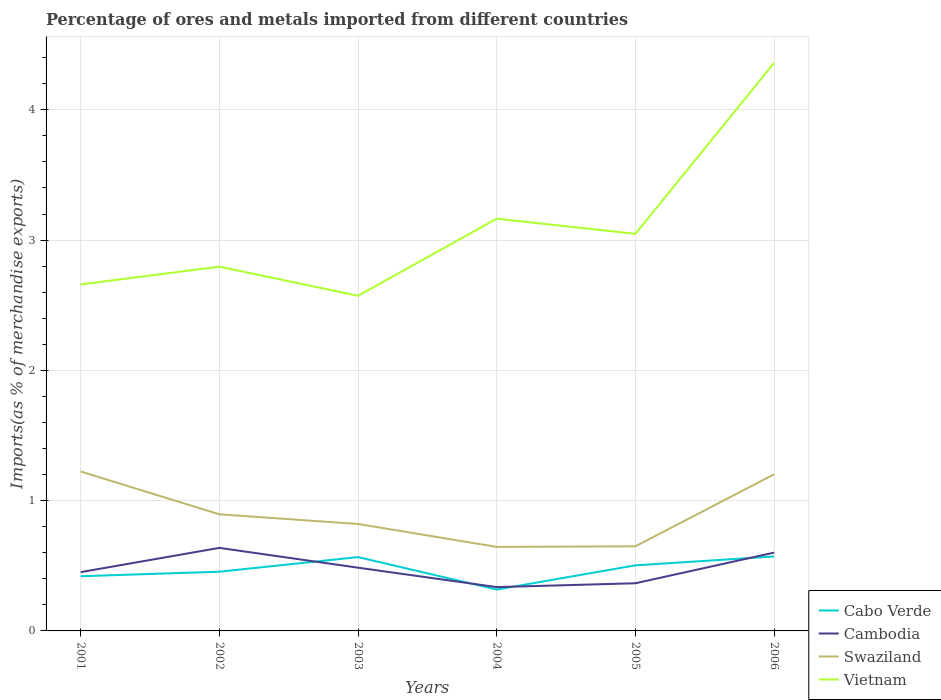Is the number of lines equal to the number of legend labels?
Your response must be concise. Yes. Across all years, what is the maximum percentage of imports to different countries in Vietnam?
Your response must be concise. 2.57. In which year was the percentage of imports to different countries in Vietnam maximum?
Keep it short and to the point. 2003. What is the total percentage of imports to different countries in Cabo Verde in the graph?
Make the answer very short. -0.15. What is the difference between the highest and the second highest percentage of imports to different countries in Vietnam?
Offer a very short reply. 1.79. What is the difference between the highest and the lowest percentage of imports to different countries in Cambodia?
Provide a succinct answer. 3. How many lines are there?
Offer a terse response. 4. What is the difference between two consecutive major ticks on the Y-axis?
Give a very brief answer. 1. Are the values on the major ticks of Y-axis written in scientific E-notation?
Offer a very short reply. No. Does the graph contain any zero values?
Provide a short and direct response. No. Where does the legend appear in the graph?
Keep it short and to the point. Bottom right. How are the legend labels stacked?
Your response must be concise. Vertical. What is the title of the graph?
Provide a short and direct response. Percentage of ores and metals imported from different countries. What is the label or title of the Y-axis?
Make the answer very short. Imports(as % of merchandise exports). What is the Imports(as % of merchandise exports) of Cabo Verde in 2001?
Give a very brief answer. 0.42. What is the Imports(as % of merchandise exports) of Cambodia in 2001?
Your answer should be very brief. 0.45. What is the Imports(as % of merchandise exports) of Swaziland in 2001?
Offer a terse response. 1.22. What is the Imports(as % of merchandise exports) in Vietnam in 2001?
Ensure brevity in your answer.  2.66. What is the Imports(as % of merchandise exports) in Cabo Verde in 2002?
Make the answer very short. 0.45. What is the Imports(as % of merchandise exports) of Cambodia in 2002?
Offer a terse response. 0.64. What is the Imports(as % of merchandise exports) in Swaziland in 2002?
Offer a very short reply. 0.9. What is the Imports(as % of merchandise exports) in Vietnam in 2002?
Your response must be concise. 2.8. What is the Imports(as % of merchandise exports) of Cabo Verde in 2003?
Offer a very short reply. 0.57. What is the Imports(as % of merchandise exports) of Cambodia in 2003?
Give a very brief answer. 0.49. What is the Imports(as % of merchandise exports) of Swaziland in 2003?
Provide a short and direct response. 0.82. What is the Imports(as % of merchandise exports) of Vietnam in 2003?
Make the answer very short. 2.57. What is the Imports(as % of merchandise exports) in Cabo Verde in 2004?
Provide a succinct answer. 0.32. What is the Imports(as % of merchandise exports) of Cambodia in 2004?
Offer a very short reply. 0.34. What is the Imports(as % of merchandise exports) of Swaziland in 2004?
Offer a very short reply. 0.65. What is the Imports(as % of merchandise exports) in Vietnam in 2004?
Give a very brief answer. 3.16. What is the Imports(as % of merchandise exports) of Cabo Verde in 2005?
Your response must be concise. 0.5. What is the Imports(as % of merchandise exports) in Cambodia in 2005?
Ensure brevity in your answer.  0.37. What is the Imports(as % of merchandise exports) of Swaziland in 2005?
Your answer should be compact. 0.65. What is the Imports(as % of merchandise exports) of Vietnam in 2005?
Make the answer very short. 3.05. What is the Imports(as % of merchandise exports) in Cabo Verde in 2006?
Provide a succinct answer. 0.57. What is the Imports(as % of merchandise exports) in Cambodia in 2006?
Keep it short and to the point. 0.6. What is the Imports(as % of merchandise exports) of Swaziland in 2006?
Keep it short and to the point. 1.2. What is the Imports(as % of merchandise exports) in Vietnam in 2006?
Make the answer very short. 4.36. Across all years, what is the maximum Imports(as % of merchandise exports) in Cabo Verde?
Offer a terse response. 0.57. Across all years, what is the maximum Imports(as % of merchandise exports) in Cambodia?
Make the answer very short. 0.64. Across all years, what is the maximum Imports(as % of merchandise exports) in Swaziland?
Make the answer very short. 1.22. Across all years, what is the maximum Imports(as % of merchandise exports) in Vietnam?
Provide a succinct answer. 4.36. Across all years, what is the minimum Imports(as % of merchandise exports) in Cabo Verde?
Provide a short and direct response. 0.32. Across all years, what is the minimum Imports(as % of merchandise exports) of Cambodia?
Offer a terse response. 0.34. Across all years, what is the minimum Imports(as % of merchandise exports) in Swaziland?
Give a very brief answer. 0.65. Across all years, what is the minimum Imports(as % of merchandise exports) of Vietnam?
Ensure brevity in your answer.  2.57. What is the total Imports(as % of merchandise exports) of Cabo Verde in the graph?
Ensure brevity in your answer.  2.83. What is the total Imports(as % of merchandise exports) in Cambodia in the graph?
Provide a succinct answer. 2.88. What is the total Imports(as % of merchandise exports) in Swaziland in the graph?
Your response must be concise. 5.44. What is the total Imports(as % of merchandise exports) in Vietnam in the graph?
Your answer should be very brief. 18.6. What is the difference between the Imports(as % of merchandise exports) in Cabo Verde in 2001 and that in 2002?
Your response must be concise. -0.03. What is the difference between the Imports(as % of merchandise exports) in Cambodia in 2001 and that in 2002?
Your answer should be compact. -0.19. What is the difference between the Imports(as % of merchandise exports) in Swaziland in 2001 and that in 2002?
Keep it short and to the point. 0.33. What is the difference between the Imports(as % of merchandise exports) in Vietnam in 2001 and that in 2002?
Provide a succinct answer. -0.14. What is the difference between the Imports(as % of merchandise exports) in Cabo Verde in 2001 and that in 2003?
Your answer should be compact. -0.15. What is the difference between the Imports(as % of merchandise exports) in Cambodia in 2001 and that in 2003?
Your response must be concise. -0.03. What is the difference between the Imports(as % of merchandise exports) in Swaziland in 2001 and that in 2003?
Your response must be concise. 0.4. What is the difference between the Imports(as % of merchandise exports) in Vietnam in 2001 and that in 2003?
Provide a short and direct response. 0.09. What is the difference between the Imports(as % of merchandise exports) in Cabo Verde in 2001 and that in 2004?
Provide a short and direct response. 0.1. What is the difference between the Imports(as % of merchandise exports) of Cambodia in 2001 and that in 2004?
Your answer should be compact. 0.11. What is the difference between the Imports(as % of merchandise exports) in Swaziland in 2001 and that in 2004?
Offer a very short reply. 0.58. What is the difference between the Imports(as % of merchandise exports) in Vietnam in 2001 and that in 2004?
Offer a terse response. -0.51. What is the difference between the Imports(as % of merchandise exports) in Cabo Verde in 2001 and that in 2005?
Your answer should be compact. -0.08. What is the difference between the Imports(as % of merchandise exports) in Cambodia in 2001 and that in 2005?
Offer a very short reply. 0.09. What is the difference between the Imports(as % of merchandise exports) in Swaziland in 2001 and that in 2005?
Provide a short and direct response. 0.57. What is the difference between the Imports(as % of merchandise exports) of Vietnam in 2001 and that in 2005?
Offer a terse response. -0.39. What is the difference between the Imports(as % of merchandise exports) in Cabo Verde in 2001 and that in 2006?
Give a very brief answer. -0.15. What is the difference between the Imports(as % of merchandise exports) of Cambodia in 2001 and that in 2006?
Your answer should be very brief. -0.15. What is the difference between the Imports(as % of merchandise exports) in Swaziland in 2001 and that in 2006?
Ensure brevity in your answer.  0.02. What is the difference between the Imports(as % of merchandise exports) in Vietnam in 2001 and that in 2006?
Give a very brief answer. -1.7. What is the difference between the Imports(as % of merchandise exports) of Cabo Verde in 2002 and that in 2003?
Your answer should be very brief. -0.11. What is the difference between the Imports(as % of merchandise exports) of Cambodia in 2002 and that in 2003?
Provide a short and direct response. 0.15. What is the difference between the Imports(as % of merchandise exports) in Swaziland in 2002 and that in 2003?
Ensure brevity in your answer.  0.07. What is the difference between the Imports(as % of merchandise exports) of Vietnam in 2002 and that in 2003?
Your response must be concise. 0.22. What is the difference between the Imports(as % of merchandise exports) in Cabo Verde in 2002 and that in 2004?
Your response must be concise. 0.14. What is the difference between the Imports(as % of merchandise exports) in Cambodia in 2002 and that in 2004?
Ensure brevity in your answer.  0.3. What is the difference between the Imports(as % of merchandise exports) of Swaziland in 2002 and that in 2004?
Give a very brief answer. 0.25. What is the difference between the Imports(as % of merchandise exports) of Vietnam in 2002 and that in 2004?
Offer a very short reply. -0.37. What is the difference between the Imports(as % of merchandise exports) of Cabo Verde in 2002 and that in 2005?
Your response must be concise. -0.05. What is the difference between the Imports(as % of merchandise exports) of Cambodia in 2002 and that in 2005?
Your answer should be compact. 0.27. What is the difference between the Imports(as % of merchandise exports) of Swaziland in 2002 and that in 2005?
Your response must be concise. 0.25. What is the difference between the Imports(as % of merchandise exports) of Vietnam in 2002 and that in 2005?
Offer a very short reply. -0.25. What is the difference between the Imports(as % of merchandise exports) of Cabo Verde in 2002 and that in 2006?
Your answer should be compact. -0.12. What is the difference between the Imports(as % of merchandise exports) in Cambodia in 2002 and that in 2006?
Your response must be concise. 0.04. What is the difference between the Imports(as % of merchandise exports) in Swaziland in 2002 and that in 2006?
Make the answer very short. -0.31. What is the difference between the Imports(as % of merchandise exports) in Vietnam in 2002 and that in 2006?
Your answer should be very brief. -1.56. What is the difference between the Imports(as % of merchandise exports) in Cabo Verde in 2003 and that in 2004?
Make the answer very short. 0.25. What is the difference between the Imports(as % of merchandise exports) in Cambodia in 2003 and that in 2004?
Your answer should be very brief. 0.15. What is the difference between the Imports(as % of merchandise exports) in Swaziland in 2003 and that in 2004?
Offer a very short reply. 0.18. What is the difference between the Imports(as % of merchandise exports) in Vietnam in 2003 and that in 2004?
Provide a succinct answer. -0.59. What is the difference between the Imports(as % of merchandise exports) in Cabo Verde in 2003 and that in 2005?
Offer a very short reply. 0.06. What is the difference between the Imports(as % of merchandise exports) of Cambodia in 2003 and that in 2005?
Your answer should be compact. 0.12. What is the difference between the Imports(as % of merchandise exports) in Swaziland in 2003 and that in 2005?
Keep it short and to the point. 0.17. What is the difference between the Imports(as % of merchandise exports) in Vietnam in 2003 and that in 2005?
Ensure brevity in your answer.  -0.48. What is the difference between the Imports(as % of merchandise exports) in Cabo Verde in 2003 and that in 2006?
Your answer should be compact. -0. What is the difference between the Imports(as % of merchandise exports) in Cambodia in 2003 and that in 2006?
Keep it short and to the point. -0.12. What is the difference between the Imports(as % of merchandise exports) in Swaziland in 2003 and that in 2006?
Provide a succinct answer. -0.38. What is the difference between the Imports(as % of merchandise exports) of Vietnam in 2003 and that in 2006?
Your answer should be compact. -1.79. What is the difference between the Imports(as % of merchandise exports) of Cabo Verde in 2004 and that in 2005?
Give a very brief answer. -0.19. What is the difference between the Imports(as % of merchandise exports) in Cambodia in 2004 and that in 2005?
Provide a succinct answer. -0.03. What is the difference between the Imports(as % of merchandise exports) in Swaziland in 2004 and that in 2005?
Provide a succinct answer. -0. What is the difference between the Imports(as % of merchandise exports) of Vietnam in 2004 and that in 2005?
Offer a very short reply. 0.12. What is the difference between the Imports(as % of merchandise exports) in Cabo Verde in 2004 and that in 2006?
Provide a short and direct response. -0.25. What is the difference between the Imports(as % of merchandise exports) of Cambodia in 2004 and that in 2006?
Your answer should be very brief. -0.26. What is the difference between the Imports(as % of merchandise exports) of Swaziland in 2004 and that in 2006?
Offer a terse response. -0.56. What is the difference between the Imports(as % of merchandise exports) in Vietnam in 2004 and that in 2006?
Your answer should be very brief. -1.2. What is the difference between the Imports(as % of merchandise exports) of Cabo Verde in 2005 and that in 2006?
Your answer should be compact. -0.07. What is the difference between the Imports(as % of merchandise exports) of Cambodia in 2005 and that in 2006?
Provide a succinct answer. -0.24. What is the difference between the Imports(as % of merchandise exports) of Swaziland in 2005 and that in 2006?
Give a very brief answer. -0.55. What is the difference between the Imports(as % of merchandise exports) of Vietnam in 2005 and that in 2006?
Your answer should be very brief. -1.31. What is the difference between the Imports(as % of merchandise exports) in Cabo Verde in 2001 and the Imports(as % of merchandise exports) in Cambodia in 2002?
Keep it short and to the point. -0.22. What is the difference between the Imports(as % of merchandise exports) in Cabo Verde in 2001 and the Imports(as % of merchandise exports) in Swaziland in 2002?
Provide a succinct answer. -0.48. What is the difference between the Imports(as % of merchandise exports) in Cabo Verde in 2001 and the Imports(as % of merchandise exports) in Vietnam in 2002?
Offer a very short reply. -2.38. What is the difference between the Imports(as % of merchandise exports) in Cambodia in 2001 and the Imports(as % of merchandise exports) in Swaziland in 2002?
Give a very brief answer. -0.44. What is the difference between the Imports(as % of merchandise exports) in Cambodia in 2001 and the Imports(as % of merchandise exports) in Vietnam in 2002?
Make the answer very short. -2.34. What is the difference between the Imports(as % of merchandise exports) of Swaziland in 2001 and the Imports(as % of merchandise exports) of Vietnam in 2002?
Provide a succinct answer. -1.57. What is the difference between the Imports(as % of merchandise exports) of Cabo Verde in 2001 and the Imports(as % of merchandise exports) of Cambodia in 2003?
Your answer should be very brief. -0.07. What is the difference between the Imports(as % of merchandise exports) in Cabo Verde in 2001 and the Imports(as % of merchandise exports) in Swaziland in 2003?
Offer a very short reply. -0.4. What is the difference between the Imports(as % of merchandise exports) of Cabo Verde in 2001 and the Imports(as % of merchandise exports) of Vietnam in 2003?
Offer a very short reply. -2.15. What is the difference between the Imports(as % of merchandise exports) in Cambodia in 2001 and the Imports(as % of merchandise exports) in Swaziland in 2003?
Give a very brief answer. -0.37. What is the difference between the Imports(as % of merchandise exports) of Cambodia in 2001 and the Imports(as % of merchandise exports) of Vietnam in 2003?
Your response must be concise. -2.12. What is the difference between the Imports(as % of merchandise exports) in Swaziland in 2001 and the Imports(as % of merchandise exports) in Vietnam in 2003?
Offer a very short reply. -1.35. What is the difference between the Imports(as % of merchandise exports) of Cabo Verde in 2001 and the Imports(as % of merchandise exports) of Cambodia in 2004?
Keep it short and to the point. 0.08. What is the difference between the Imports(as % of merchandise exports) in Cabo Verde in 2001 and the Imports(as % of merchandise exports) in Swaziland in 2004?
Your answer should be compact. -0.23. What is the difference between the Imports(as % of merchandise exports) of Cabo Verde in 2001 and the Imports(as % of merchandise exports) of Vietnam in 2004?
Make the answer very short. -2.74. What is the difference between the Imports(as % of merchandise exports) in Cambodia in 2001 and the Imports(as % of merchandise exports) in Swaziland in 2004?
Offer a very short reply. -0.19. What is the difference between the Imports(as % of merchandise exports) in Cambodia in 2001 and the Imports(as % of merchandise exports) in Vietnam in 2004?
Offer a very short reply. -2.71. What is the difference between the Imports(as % of merchandise exports) in Swaziland in 2001 and the Imports(as % of merchandise exports) in Vietnam in 2004?
Give a very brief answer. -1.94. What is the difference between the Imports(as % of merchandise exports) in Cabo Verde in 2001 and the Imports(as % of merchandise exports) in Cambodia in 2005?
Your answer should be compact. 0.05. What is the difference between the Imports(as % of merchandise exports) in Cabo Verde in 2001 and the Imports(as % of merchandise exports) in Swaziland in 2005?
Provide a short and direct response. -0.23. What is the difference between the Imports(as % of merchandise exports) in Cabo Verde in 2001 and the Imports(as % of merchandise exports) in Vietnam in 2005?
Offer a terse response. -2.63. What is the difference between the Imports(as % of merchandise exports) of Cambodia in 2001 and the Imports(as % of merchandise exports) of Swaziland in 2005?
Your answer should be very brief. -0.2. What is the difference between the Imports(as % of merchandise exports) in Cambodia in 2001 and the Imports(as % of merchandise exports) in Vietnam in 2005?
Offer a terse response. -2.6. What is the difference between the Imports(as % of merchandise exports) of Swaziland in 2001 and the Imports(as % of merchandise exports) of Vietnam in 2005?
Provide a short and direct response. -1.82. What is the difference between the Imports(as % of merchandise exports) of Cabo Verde in 2001 and the Imports(as % of merchandise exports) of Cambodia in 2006?
Ensure brevity in your answer.  -0.18. What is the difference between the Imports(as % of merchandise exports) in Cabo Verde in 2001 and the Imports(as % of merchandise exports) in Swaziland in 2006?
Your answer should be very brief. -0.78. What is the difference between the Imports(as % of merchandise exports) in Cabo Verde in 2001 and the Imports(as % of merchandise exports) in Vietnam in 2006?
Keep it short and to the point. -3.94. What is the difference between the Imports(as % of merchandise exports) of Cambodia in 2001 and the Imports(as % of merchandise exports) of Swaziland in 2006?
Provide a succinct answer. -0.75. What is the difference between the Imports(as % of merchandise exports) of Cambodia in 2001 and the Imports(as % of merchandise exports) of Vietnam in 2006?
Offer a terse response. -3.91. What is the difference between the Imports(as % of merchandise exports) of Swaziland in 2001 and the Imports(as % of merchandise exports) of Vietnam in 2006?
Your response must be concise. -3.14. What is the difference between the Imports(as % of merchandise exports) of Cabo Verde in 2002 and the Imports(as % of merchandise exports) of Cambodia in 2003?
Make the answer very short. -0.03. What is the difference between the Imports(as % of merchandise exports) of Cabo Verde in 2002 and the Imports(as % of merchandise exports) of Swaziland in 2003?
Ensure brevity in your answer.  -0.37. What is the difference between the Imports(as % of merchandise exports) of Cabo Verde in 2002 and the Imports(as % of merchandise exports) of Vietnam in 2003?
Make the answer very short. -2.12. What is the difference between the Imports(as % of merchandise exports) in Cambodia in 2002 and the Imports(as % of merchandise exports) in Swaziland in 2003?
Your response must be concise. -0.18. What is the difference between the Imports(as % of merchandise exports) in Cambodia in 2002 and the Imports(as % of merchandise exports) in Vietnam in 2003?
Ensure brevity in your answer.  -1.94. What is the difference between the Imports(as % of merchandise exports) in Swaziland in 2002 and the Imports(as % of merchandise exports) in Vietnam in 2003?
Make the answer very short. -1.68. What is the difference between the Imports(as % of merchandise exports) of Cabo Verde in 2002 and the Imports(as % of merchandise exports) of Cambodia in 2004?
Your response must be concise. 0.12. What is the difference between the Imports(as % of merchandise exports) in Cabo Verde in 2002 and the Imports(as % of merchandise exports) in Swaziland in 2004?
Provide a succinct answer. -0.19. What is the difference between the Imports(as % of merchandise exports) in Cabo Verde in 2002 and the Imports(as % of merchandise exports) in Vietnam in 2004?
Offer a terse response. -2.71. What is the difference between the Imports(as % of merchandise exports) of Cambodia in 2002 and the Imports(as % of merchandise exports) of Swaziland in 2004?
Provide a succinct answer. -0.01. What is the difference between the Imports(as % of merchandise exports) in Cambodia in 2002 and the Imports(as % of merchandise exports) in Vietnam in 2004?
Offer a very short reply. -2.53. What is the difference between the Imports(as % of merchandise exports) of Swaziland in 2002 and the Imports(as % of merchandise exports) of Vietnam in 2004?
Ensure brevity in your answer.  -2.27. What is the difference between the Imports(as % of merchandise exports) in Cabo Verde in 2002 and the Imports(as % of merchandise exports) in Cambodia in 2005?
Offer a terse response. 0.09. What is the difference between the Imports(as % of merchandise exports) in Cabo Verde in 2002 and the Imports(as % of merchandise exports) in Swaziland in 2005?
Offer a terse response. -0.19. What is the difference between the Imports(as % of merchandise exports) of Cabo Verde in 2002 and the Imports(as % of merchandise exports) of Vietnam in 2005?
Make the answer very short. -2.59. What is the difference between the Imports(as % of merchandise exports) of Cambodia in 2002 and the Imports(as % of merchandise exports) of Swaziland in 2005?
Offer a terse response. -0.01. What is the difference between the Imports(as % of merchandise exports) in Cambodia in 2002 and the Imports(as % of merchandise exports) in Vietnam in 2005?
Provide a short and direct response. -2.41. What is the difference between the Imports(as % of merchandise exports) in Swaziland in 2002 and the Imports(as % of merchandise exports) in Vietnam in 2005?
Make the answer very short. -2.15. What is the difference between the Imports(as % of merchandise exports) of Cabo Verde in 2002 and the Imports(as % of merchandise exports) of Cambodia in 2006?
Provide a short and direct response. -0.15. What is the difference between the Imports(as % of merchandise exports) of Cabo Verde in 2002 and the Imports(as % of merchandise exports) of Swaziland in 2006?
Provide a succinct answer. -0.75. What is the difference between the Imports(as % of merchandise exports) of Cabo Verde in 2002 and the Imports(as % of merchandise exports) of Vietnam in 2006?
Offer a very short reply. -3.91. What is the difference between the Imports(as % of merchandise exports) in Cambodia in 2002 and the Imports(as % of merchandise exports) in Swaziland in 2006?
Your answer should be compact. -0.56. What is the difference between the Imports(as % of merchandise exports) in Cambodia in 2002 and the Imports(as % of merchandise exports) in Vietnam in 2006?
Give a very brief answer. -3.72. What is the difference between the Imports(as % of merchandise exports) of Swaziland in 2002 and the Imports(as % of merchandise exports) of Vietnam in 2006?
Offer a terse response. -3.46. What is the difference between the Imports(as % of merchandise exports) in Cabo Verde in 2003 and the Imports(as % of merchandise exports) in Cambodia in 2004?
Give a very brief answer. 0.23. What is the difference between the Imports(as % of merchandise exports) in Cabo Verde in 2003 and the Imports(as % of merchandise exports) in Swaziland in 2004?
Keep it short and to the point. -0.08. What is the difference between the Imports(as % of merchandise exports) of Cabo Verde in 2003 and the Imports(as % of merchandise exports) of Vietnam in 2004?
Provide a succinct answer. -2.6. What is the difference between the Imports(as % of merchandise exports) of Cambodia in 2003 and the Imports(as % of merchandise exports) of Swaziland in 2004?
Offer a very short reply. -0.16. What is the difference between the Imports(as % of merchandise exports) of Cambodia in 2003 and the Imports(as % of merchandise exports) of Vietnam in 2004?
Ensure brevity in your answer.  -2.68. What is the difference between the Imports(as % of merchandise exports) of Swaziland in 2003 and the Imports(as % of merchandise exports) of Vietnam in 2004?
Make the answer very short. -2.34. What is the difference between the Imports(as % of merchandise exports) of Cabo Verde in 2003 and the Imports(as % of merchandise exports) of Cambodia in 2005?
Make the answer very short. 0.2. What is the difference between the Imports(as % of merchandise exports) of Cabo Verde in 2003 and the Imports(as % of merchandise exports) of Swaziland in 2005?
Provide a short and direct response. -0.08. What is the difference between the Imports(as % of merchandise exports) of Cabo Verde in 2003 and the Imports(as % of merchandise exports) of Vietnam in 2005?
Ensure brevity in your answer.  -2.48. What is the difference between the Imports(as % of merchandise exports) in Cambodia in 2003 and the Imports(as % of merchandise exports) in Swaziland in 2005?
Your answer should be very brief. -0.16. What is the difference between the Imports(as % of merchandise exports) of Cambodia in 2003 and the Imports(as % of merchandise exports) of Vietnam in 2005?
Make the answer very short. -2.56. What is the difference between the Imports(as % of merchandise exports) of Swaziland in 2003 and the Imports(as % of merchandise exports) of Vietnam in 2005?
Give a very brief answer. -2.23. What is the difference between the Imports(as % of merchandise exports) of Cabo Verde in 2003 and the Imports(as % of merchandise exports) of Cambodia in 2006?
Keep it short and to the point. -0.03. What is the difference between the Imports(as % of merchandise exports) in Cabo Verde in 2003 and the Imports(as % of merchandise exports) in Swaziland in 2006?
Offer a terse response. -0.64. What is the difference between the Imports(as % of merchandise exports) of Cabo Verde in 2003 and the Imports(as % of merchandise exports) of Vietnam in 2006?
Make the answer very short. -3.79. What is the difference between the Imports(as % of merchandise exports) of Cambodia in 2003 and the Imports(as % of merchandise exports) of Swaziland in 2006?
Offer a terse response. -0.72. What is the difference between the Imports(as % of merchandise exports) in Cambodia in 2003 and the Imports(as % of merchandise exports) in Vietnam in 2006?
Make the answer very short. -3.87. What is the difference between the Imports(as % of merchandise exports) in Swaziland in 2003 and the Imports(as % of merchandise exports) in Vietnam in 2006?
Provide a succinct answer. -3.54. What is the difference between the Imports(as % of merchandise exports) in Cabo Verde in 2004 and the Imports(as % of merchandise exports) in Cambodia in 2005?
Your answer should be compact. -0.05. What is the difference between the Imports(as % of merchandise exports) of Cabo Verde in 2004 and the Imports(as % of merchandise exports) of Swaziland in 2005?
Your answer should be compact. -0.33. What is the difference between the Imports(as % of merchandise exports) in Cabo Verde in 2004 and the Imports(as % of merchandise exports) in Vietnam in 2005?
Your response must be concise. -2.73. What is the difference between the Imports(as % of merchandise exports) of Cambodia in 2004 and the Imports(as % of merchandise exports) of Swaziland in 2005?
Your answer should be compact. -0.31. What is the difference between the Imports(as % of merchandise exports) of Cambodia in 2004 and the Imports(as % of merchandise exports) of Vietnam in 2005?
Offer a very short reply. -2.71. What is the difference between the Imports(as % of merchandise exports) in Swaziland in 2004 and the Imports(as % of merchandise exports) in Vietnam in 2005?
Keep it short and to the point. -2.4. What is the difference between the Imports(as % of merchandise exports) in Cabo Verde in 2004 and the Imports(as % of merchandise exports) in Cambodia in 2006?
Your answer should be compact. -0.28. What is the difference between the Imports(as % of merchandise exports) in Cabo Verde in 2004 and the Imports(as % of merchandise exports) in Swaziland in 2006?
Your answer should be compact. -0.88. What is the difference between the Imports(as % of merchandise exports) of Cabo Verde in 2004 and the Imports(as % of merchandise exports) of Vietnam in 2006?
Give a very brief answer. -4.04. What is the difference between the Imports(as % of merchandise exports) in Cambodia in 2004 and the Imports(as % of merchandise exports) in Swaziland in 2006?
Provide a short and direct response. -0.87. What is the difference between the Imports(as % of merchandise exports) of Cambodia in 2004 and the Imports(as % of merchandise exports) of Vietnam in 2006?
Provide a succinct answer. -4.02. What is the difference between the Imports(as % of merchandise exports) of Swaziland in 2004 and the Imports(as % of merchandise exports) of Vietnam in 2006?
Keep it short and to the point. -3.71. What is the difference between the Imports(as % of merchandise exports) in Cabo Verde in 2005 and the Imports(as % of merchandise exports) in Cambodia in 2006?
Offer a very short reply. -0.1. What is the difference between the Imports(as % of merchandise exports) in Cabo Verde in 2005 and the Imports(as % of merchandise exports) in Swaziland in 2006?
Your answer should be compact. -0.7. What is the difference between the Imports(as % of merchandise exports) of Cabo Verde in 2005 and the Imports(as % of merchandise exports) of Vietnam in 2006?
Offer a terse response. -3.86. What is the difference between the Imports(as % of merchandise exports) in Cambodia in 2005 and the Imports(as % of merchandise exports) in Swaziland in 2006?
Provide a short and direct response. -0.84. What is the difference between the Imports(as % of merchandise exports) of Cambodia in 2005 and the Imports(as % of merchandise exports) of Vietnam in 2006?
Keep it short and to the point. -3.99. What is the difference between the Imports(as % of merchandise exports) of Swaziland in 2005 and the Imports(as % of merchandise exports) of Vietnam in 2006?
Provide a succinct answer. -3.71. What is the average Imports(as % of merchandise exports) of Cabo Verde per year?
Ensure brevity in your answer.  0.47. What is the average Imports(as % of merchandise exports) of Cambodia per year?
Ensure brevity in your answer.  0.48. What is the average Imports(as % of merchandise exports) of Swaziland per year?
Your answer should be compact. 0.91. In the year 2001, what is the difference between the Imports(as % of merchandise exports) of Cabo Verde and Imports(as % of merchandise exports) of Cambodia?
Offer a terse response. -0.03. In the year 2001, what is the difference between the Imports(as % of merchandise exports) of Cabo Verde and Imports(as % of merchandise exports) of Swaziland?
Make the answer very short. -0.8. In the year 2001, what is the difference between the Imports(as % of merchandise exports) in Cabo Verde and Imports(as % of merchandise exports) in Vietnam?
Your answer should be very brief. -2.24. In the year 2001, what is the difference between the Imports(as % of merchandise exports) in Cambodia and Imports(as % of merchandise exports) in Swaziland?
Make the answer very short. -0.77. In the year 2001, what is the difference between the Imports(as % of merchandise exports) of Cambodia and Imports(as % of merchandise exports) of Vietnam?
Keep it short and to the point. -2.21. In the year 2001, what is the difference between the Imports(as % of merchandise exports) in Swaziland and Imports(as % of merchandise exports) in Vietnam?
Offer a terse response. -1.44. In the year 2002, what is the difference between the Imports(as % of merchandise exports) of Cabo Verde and Imports(as % of merchandise exports) of Cambodia?
Your response must be concise. -0.18. In the year 2002, what is the difference between the Imports(as % of merchandise exports) in Cabo Verde and Imports(as % of merchandise exports) in Swaziland?
Provide a succinct answer. -0.44. In the year 2002, what is the difference between the Imports(as % of merchandise exports) in Cabo Verde and Imports(as % of merchandise exports) in Vietnam?
Give a very brief answer. -2.34. In the year 2002, what is the difference between the Imports(as % of merchandise exports) of Cambodia and Imports(as % of merchandise exports) of Swaziland?
Your answer should be very brief. -0.26. In the year 2002, what is the difference between the Imports(as % of merchandise exports) in Cambodia and Imports(as % of merchandise exports) in Vietnam?
Offer a very short reply. -2.16. In the year 2002, what is the difference between the Imports(as % of merchandise exports) in Swaziland and Imports(as % of merchandise exports) in Vietnam?
Provide a short and direct response. -1.9. In the year 2003, what is the difference between the Imports(as % of merchandise exports) of Cabo Verde and Imports(as % of merchandise exports) of Cambodia?
Provide a short and direct response. 0.08. In the year 2003, what is the difference between the Imports(as % of merchandise exports) of Cabo Verde and Imports(as % of merchandise exports) of Swaziland?
Your answer should be compact. -0.25. In the year 2003, what is the difference between the Imports(as % of merchandise exports) in Cabo Verde and Imports(as % of merchandise exports) in Vietnam?
Ensure brevity in your answer.  -2.01. In the year 2003, what is the difference between the Imports(as % of merchandise exports) in Cambodia and Imports(as % of merchandise exports) in Swaziland?
Give a very brief answer. -0.34. In the year 2003, what is the difference between the Imports(as % of merchandise exports) in Cambodia and Imports(as % of merchandise exports) in Vietnam?
Keep it short and to the point. -2.09. In the year 2003, what is the difference between the Imports(as % of merchandise exports) of Swaziland and Imports(as % of merchandise exports) of Vietnam?
Your answer should be compact. -1.75. In the year 2004, what is the difference between the Imports(as % of merchandise exports) in Cabo Verde and Imports(as % of merchandise exports) in Cambodia?
Your response must be concise. -0.02. In the year 2004, what is the difference between the Imports(as % of merchandise exports) of Cabo Verde and Imports(as % of merchandise exports) of Swaziland?
Your answer should be very brief. -0.33. In the year 2004, what is the difference between the Imports(as % of merchandise exports) in Cabo Verde and Imports(as % of merchandise exports) in Vietnam?
Offer a terse response. -2.85. In the year 2004, what is the difference between the Imports(as % of merchandise exports) of Cambodia and Imports(as % of merchandise exports) of Swaziland?
Give a very brief answer. -0.31. In the year 2004, what is the difference between the Imports(as % of merchandise exports) of Cambodia and Imports(as % of merchandise exports) of Vietnam?
Keep it short and to the point. -2.83. In the year 2004, what is the difference between the Imports(as % of merchandise exports) of Swaziland and Imports(as % of merchandise exports) of Vietnam?
Your response must be concise. -2.52. In the year 2005, what is the difference between the Imports(as % of merchandise exports) in Cabo Verde and Imports(as % of merchandise exports) in Cambodia?
Offer a terse response. 0.14. In the year 2005, what is the difference between the Imports(as % of merchandise exports) of Cabo Verde and Imports(as % of merchandise exports) of Swaziland?
Provide a short and direct response. -0.15. In the year 2005, what is the difference between the Imports(as % of merchandise exports) in Cabo Verde and Imports(as % of merchandise exports) in Vietnam?
Your response must be concise. -2.54. In the year 2005, what is the difference between the Imports(as % of merchandise exports) in Cambodia and Imports(as % of merchandise exports) in Swaziland?
Your answer should be compact. -0.28. In the year 2005, what is the difference between the Imports(as % of merchandise exports) in Cambodia and Imports(as % of merchandise exports) in Vietnam?
Ensure brevity in your answer.  -2.68. In the year 2005, what is the difference between the Imports(as % of merchandise exports) in Swaziland and Imports(as % of merchandise exports) in Vietnam?
Your response must be concise. -2.4. In the year 2006, what is the difference between the Imports(as % of merchandise exports) of Cabo Verde and Imports(as % of merchandise exports) of Cambodia?
Make the answer very short. -0.03. In the year 2006, what is the difference between the Imports(as % of merchandise exports) of Cabo Verde and Imports(as % of merchandise exports) of Swaziland?
Your answer should be compact. -0.63. In the year 2006, what is the difference between the Imports(as % of merchandise exports) of Cabo Verde and Imports(as % of merchandise exports) of Vietnam?
Keep it short and to the point. -3.79. In the year 2006, what is the difference between the Imports(as % of merchandise exports) in Cambodia and Imports(as % of merchandise exports) in Swaziland?
Make the answer very short. -0.6. In the year 2006, what is the difference between the Imports(as % of merchandise exports) of Cambodia and Imports(as % of merchandise exports) of Vietnam?
Offer a very short reply. -3.76. In the year 2006, what is the difference between the Imports(as % of merchandise exports) of Swaziland and Imports(as % of merchandise exports) of Vietnam?
Offer a terse response. -3.16. What is the ratio of the Imports(as % of merchandise exports) in Cabo Verde in 2001 to that in 2002?
Make the answer very short. 0.92. What is the ratio of the Imports(as % of merchandise exports) in Cambodia in 2001 to that in 2002?
Offer a very short reply. 0.71. What is the ratio of the Imports(as % of merchandise exports) of Swaziland in 2001 to that in 2002?
Your answer should be very brief. 1.37. What is the ratio of the Imports(as % of merchandise exports) of Vietnam in 2001 to that in 2002?
Offer a terse response. 0.95. What is the ratio of the Imports(as % of merchandise exports) of Cabo Verde in 2001 to that in 2003?
Your answer should be very brief. 0.74. What is the ratio of the Imports(as % of merchandise exports) in Cambodia in 2001 to that in 2003?
Ensure brevity in your answer.  0.93. What is the ratio of the Imports(as % of merchandise exports) in Swaziland in 2001 to that in 2003?
Offer a very short reply. 1.49. What is the ratio of the Imports(as % of merchandise exports) of Vietnam in 2001 to that in 2003?
Offer a terse response. 1.03. What is the ratio of the Imports(as % of merchandise exports) in Cabo Verde in 2001 to that in 2004?
Your answer should be compact. 1.32. What is the ratio of the Imports(as % of merchandise exports) in Cambodia in 2001 to that in 2004?
Make the answer very short. 1.34. What is the ratio of the Imports(as % of merchandise exports) of Swaziland in 2001 to that in 2004?
Provide a short and direct response. 1.9. What is the ratio of the Imports(as % of merchandise exports) of Vietnam in 2001 to that in 2004?
Make the answer very short. 0.84. What is the ratio of the Imports(as % of merchandise exports) of Cabo Verde in 2001 to that in 2005?
Provide a short and direct response. 0.83. What is the ratio of the Imports(as % of merchandise exports) in Cambodia in 2001 to that in 2005?
Offer a very short reply. 1.23. What is the ratio of the Imports(as % of merchandise exports) in Swaziland in 2001 to that in 2005?
Ensure brevity in your answer.  1.88. What is the ratio of the Imports(as % of merchandise exports) of Vietnam in 2001 to that in 2005?
Your answer should be compact. 0.87. What is the ratio of the Imports(as % of merchandise exports) of Cabo Verde in 2001 to that in 2006?
Your answer should be compact. 0.73. What is the ratio of the Imports(as % of merchandise exports) of Cambodia in 2001 to that in 2006?
Ensure brevity in your answer.  0.75. What is the ratio of the Imports(as % of merchandise exports) in Swaziland in 2001 to that in 2006?
Provide a short and direct response. 1.02. What is the ratio of the Imports(as % of merchandise exports) of Vietnam in 2001 to that in 2006?
Your answer should be very brief. 0.61. What is the ratio of the Imports(as % of merchandise exports) in Cabo Verde in 2002 to that in 2003?
Provide a short and direct response. 0.8. What is the ratio of the Imports(as % of merchandise exports) of Cambodia in 2002 to that in 2003?
Your answer should be compact. 1.31. What is the ratio of the Imports(as % of merchandise exports) of Swaziland in 2002 to that in 2003?
Keep it short and to the point. 1.09. What is the ratio of the Imports(as % of merchandise exports) in Vietnam in 2002 to that in 2003?
Your answer should be compact. 1.09. What is the ratio of the Imports(as % of merchandise exports) of Cabo Verde in 2002 to that in 2004?
Your response must be concise. 1.43. What is the ratio of the Imports(as % of merchandise exports) in Cambodia in 2002 to that in 2004?
Your answer should be compact. 1.89. What is the ratio of the Imports(as % of merchandise exports) in Swaziland in 2002 to that in 2004?
Your response must be concise. 1.39. What is the ratio of the Imports(as % of merchandise exports) in Vietnam in 2002 to that in 2004?
Your answer should be very brief. 0.88. What is the ratio of the Imports(as % of merchandise exports) of Cabo Verde in 2002 to that in 2005?
Provide a succinct answer. 0.9. What is the ratio of the Imports(as % of merchandise exports) of Cambodia in 2002 to that in 2005?
Ensure brevity in your answer.  1.74. What is the ratio of the Imports(as % of merchandise exports) in Swaziland in 2002 to that in 2005?
Ensure brevity in your answer.  1.38. What is the ratio of the Imports(as % of merchandise exports) of Vietnam in 2002 to that in 2005?
Give a very brief answer. 0.92. What is the ratio of the Imports(as % of merchandise exports) of Cabo Verde in 2002 to that in 2006?
Your answer should be very brief. 0.8. What is the ratio of the Imports(as % of merchandise exports) of Cambodia in 2002 to that in 2006?
Provide a short and direct response. 1.06. What is the ratio of the Imports(as % of merchandise exports) in Swaziland in 2002 to that in 2006?
Your answer should be very brief. 0.74. What is the ratio of the Imports(as % of merchandise exports) in Vietnam in 2002 to that in 2006?
Keep it short and to the point. 0.64. What is the ratio of the Imports(as % of merchandise exports) of Cabo Verde in 2003 to that in 2004?
Keep it short and to the point. 1.78. What is the ratio of the Imports(as % of merchandise exports) in Cambodia in 2003 to that in 2004?
Your response must be concise. 1.44. What is the ratio of the Imports(as % of merchandise exports) of Swaziland in 2003 to that in 2004?
Offer a very short reply. 1.27. What is the ratio of the Imports(as % of merchandise exports) of Vietnam in 2003 to that in 2004?
Your answer should be compact. 0.81. What is the ratio of the Imports(as % of merchandise exports) in Cabo Verde in 2003 to that in 2005?
Offer a terse response. 1.13. What is the ratio of the Imports(as % of merchandise exports) of Cambodia in 2003 to that in 2005?
Your response must be concise. 1.33. What is the ratio of the Imports(as % of merchandise exports) in Swaziland in 2003 to that in 2005?
Your response must be concise. 1.26. What is the ratio of the Imports(as % of merchandise exports) in Vietnam in 2003 to that in 2005?
Your answer should be compact. 0.84. What is the ratio of the Imports(as % of merchandise exports) of Cambodia in 2003 to that in 2006?
Give a very brief answer. 0.81. What is the ratio of the Imports(as % of merchandise exports) in Swaziland in 2003 to that in 2006?
Your response must be concise. 0.68. What is the ratio of the Imports(as % of merchandise exports) of Vietnam in 2003 to that in 2006?
Provide a succinct answer. 0.59. What is the ratio of the Imports(as % of merchandise exports) of Cabo Verde in 2004 to that in 2005?
Provide a succinct answer. 0.63. What is the ratio of the Imports(as % of merchandise exports) in Cambodia in 2004 to that in 2005?
Your answer should be very brief. 0.92. What is the ratio of the Imports(as % of merchandise exports) in Swaziland in 2004 to that in 2005?
Make the answer very short. 0.99. What is the ratio of the Imports(as % of merchandise exports) of Vietnam in 2004 to that in 2005?
Your response must be concise. 1.04. What is the ratio of the Imports(as % of merchandise exports) in Cabo Verde in 2004 to that in 2006?
Make the answer very short. 0.56. What is the ratio of the Imports(as % of merchandise exports) of Cambodia in 2004 to that in 2006?
Your answer should be very brief. 0.56. What is the ratio of the Imports(as % of merchandise exports) in Swaziland in 2004 to that in 2006?
Give a very brief answer. 0.54. What is the ratio of the Imports(as % of merchandise exports) in Vietnam in 2004 to that in 2006?
Provide a short and direct response. 0.73. What is the ratio of the Imports(as % of merchandise exports) in Cabo Verde in 2005 to that in 2006?
Offer a terse response. 0.88. What is the ratio of the Imports(as % of merchandise exports) of Cambodia in 2005 to that in 2006?
Ensure brevity in your answer.  0.61. What is the ratio of the Imports(as % of merchandise exports) of Swaziland in 2005 to that in 2006?
Keep it short and to the point. 0.54. What is the ratio of the Imports(as % of merchandise exports) of Vietnam in 2005 to that in 2006?
Ensure brevity in your answer.  0.7. What is the difference between the highest and the second highest Imports(as % of merchandise exports) in Cabo Verde?
Give a very brief answer. 0. What is the difference between the highest and the second highest Imports(as % of merchandise exports) in Cambodia?
Make the answer very short. 0.04. What is the difference between the highest and the second highest Imports(as % of merchandise exports) in Swaziland?
Give a very brief answer. 0.02. What is the difference between the highest and the second highest Imports(as % of merchandise exports) of Vietnam?
Offer a terse response. 1.2. What is the difference between the highest and the lowest Imports(as % of merchandise exports) of Cabo Verde?
Offer a terse response. 0.25. What is the difference between the highest and the lowest Imports(as % of merchandise exports) in Cambodia?
Make the answer very short. 0.3. What is the difference between the highest and the lowest Imports(as % of merchandise exports) in Swaziland?
Your response must be concise. 0.58. What is the difference between the highest and the lowest Imports(as % of merchandise exports) in Vietnam?
Ensure brevity in your answer.  1.79. 